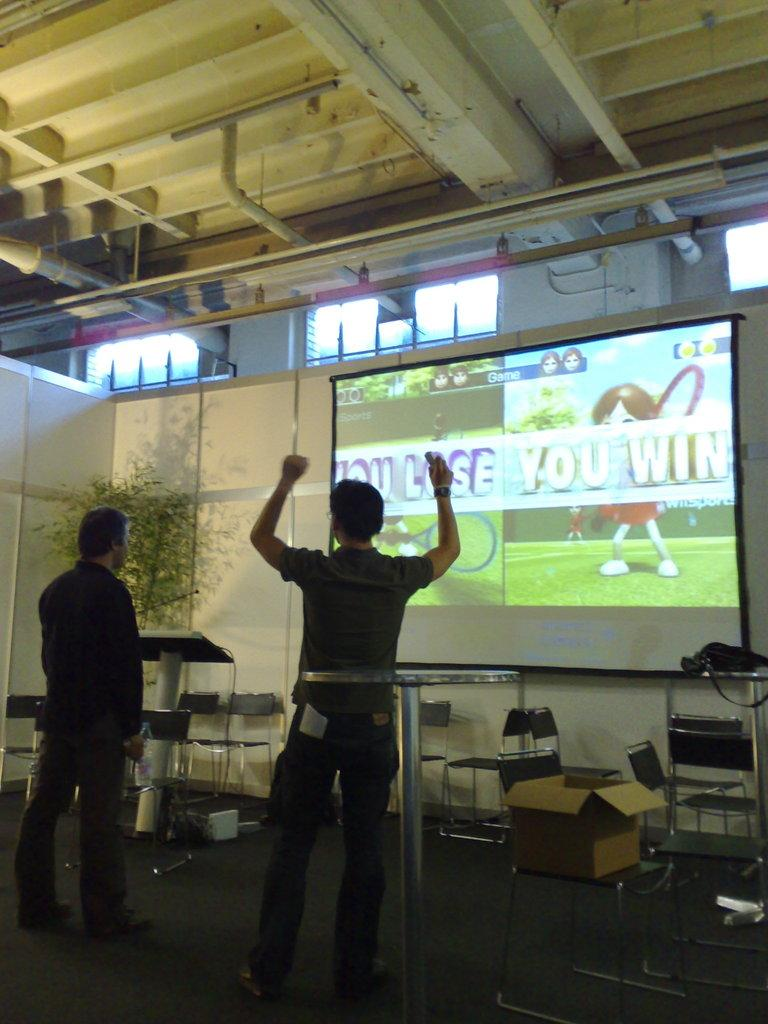Provide a one-sentence caption for the provided image. The man on the right won the game. 